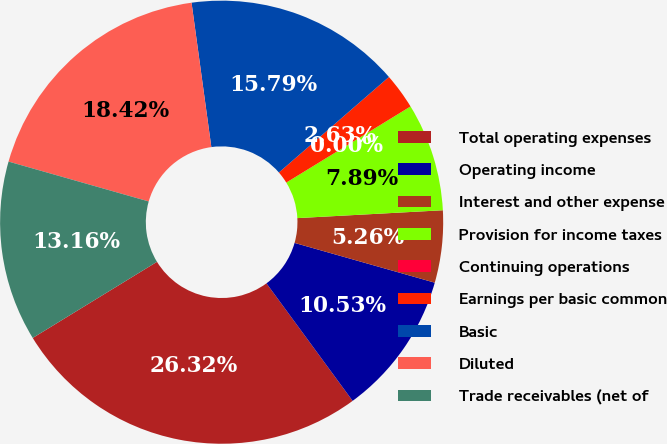<chart> <loc_0><loc_0><loc_500><loc_500><pie_chart><fcel>Total operating expenses<fcel>Operating income<fcel>Interest and other expense<fcel>Provision for income taxes<fcel>Continuing operations<fcel>Earnings per basic common<fcel>Basic<fcel>Diluted<fcel>Trade receivables (net of<nl><fcel>26.32%<fcel>10.53%<fcel>5.26%<fcel>7.89%<fcel>0.0%<fcel>2.63%<fcel>15.79%<fcel>18.42%<fcel>13.16%<nl></chart> 